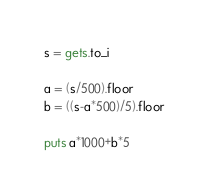<code> <loc_0><loc_0><loc_500><loc_500><_Ruby_>s = gets.to_i

a = (s/500).floor
b = ((s-a*500)/5).floor

puts a*1000+b*5</code> 